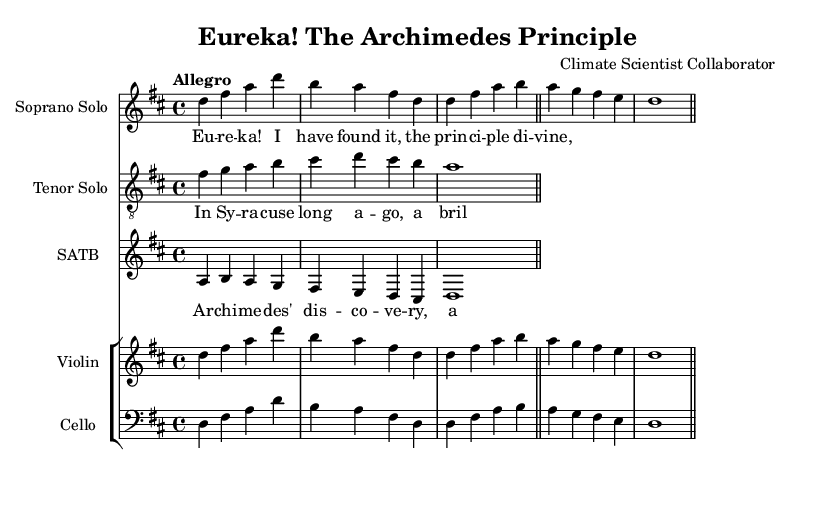What is the key signature of this music? The key signature is identified at the beginning of the staff where the sharp symbols are placed. Here, the signature indicates two sharps, which correspond to F sharp and C sharp. This confirms that the piece is in D major.
Answer: D major What is the time signature of this music? The time signature is located at the beginning of the staff, showing the numeral notation that indicates how many beats are in each measure. Here, it is represented as 4/4. This means there are four beats in each measure and the quarter note receives one beat.
Answer: 4/4 What is the tempo marking for this music? The tempo marking is placed at the beginning of the score, giving specific performance instructions. In this case, it is indicated as "Allegro," which suggests a fast and lively pace of performance.
Answer: Allegro Who is the composer of this opera? The composer's name is presented in the header section of the score, specifically marked as "composer." Here it states "Climate Scientist Collaborator," revealing their identity.
Answer: Climate Scientist Collaborator How many voices are included in the chorus? The score shows a choir staff that typically consists of multiple voice parts. In this case, the chorus is specifically listed as SATB (Soprano, Alto, Tenor, Bass), meaning it includes four distinct voice parts.
Answer: 4 What is the significance of the lyrics "Eureka! I have found it"? The lyrics "Eureka! I have found it" are component phrases from the vocal part, specifically sung by the soprano soloist. This phrase relates to Archimedes and celebrates the discovery of a scientific principle, reflecting the theme of operatic adaptations of scientific discoveries.
Answer: Celebration of discovery 